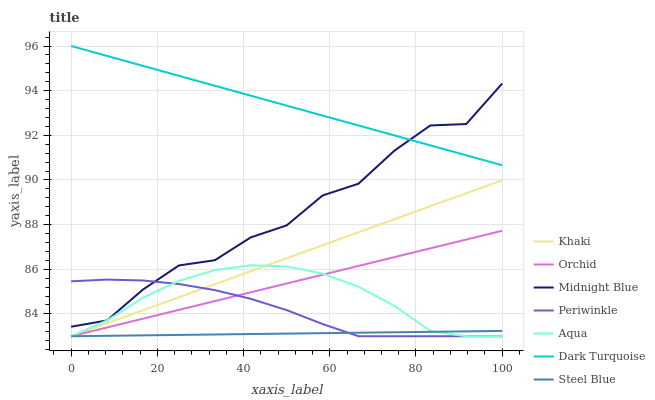Does Steel Blue have the minimum area under the curve?
Answer yes or no. Yes. Does Dark Turquoise have the maximum area under the curve?
Answer yes or no. Yes. Does Midnight Blue have the minimum area under the curve?
Answer yes or no. No. Does Midnight Blue have the maximum area under the curve?
Answer yes or no. No. Is Dark Turquoise the smoothest?
Answer yes or no. Yes. Is Midnight Blue the roughest?
Answer yes or no. Yes. Is Midnight Blue the smoothest?
Answer yes or no. No. Is Dark Turquoise the roughest?
Answer yes or no. No. Does Khaki have the lowest value?
Answer yes or no. Yes. Does Midnight Blue have the lowest value?
Answer yes or no. No. Does Dark Turquoise have the highest value?
Answer yes or no. Yes. Does Midnight Blue have the highest value?
Answer yes or no. No. Is Aqua less than Midnight Blue?
Answer yes or no. Yes. Is Midnight Blue greater than Khaki?
Answer yes or no. Yes. Does Steel Blue intersect Periwinkle?
Answer yes or no. Yes. Is Steel Blue less than Periwinkle?
Answer yes or no. No. Is Steel Blue greater than Periwinkle?
Answer yes or no. No. Does Aqua intersect Midnight Blue?
Answer yes or no. No. 